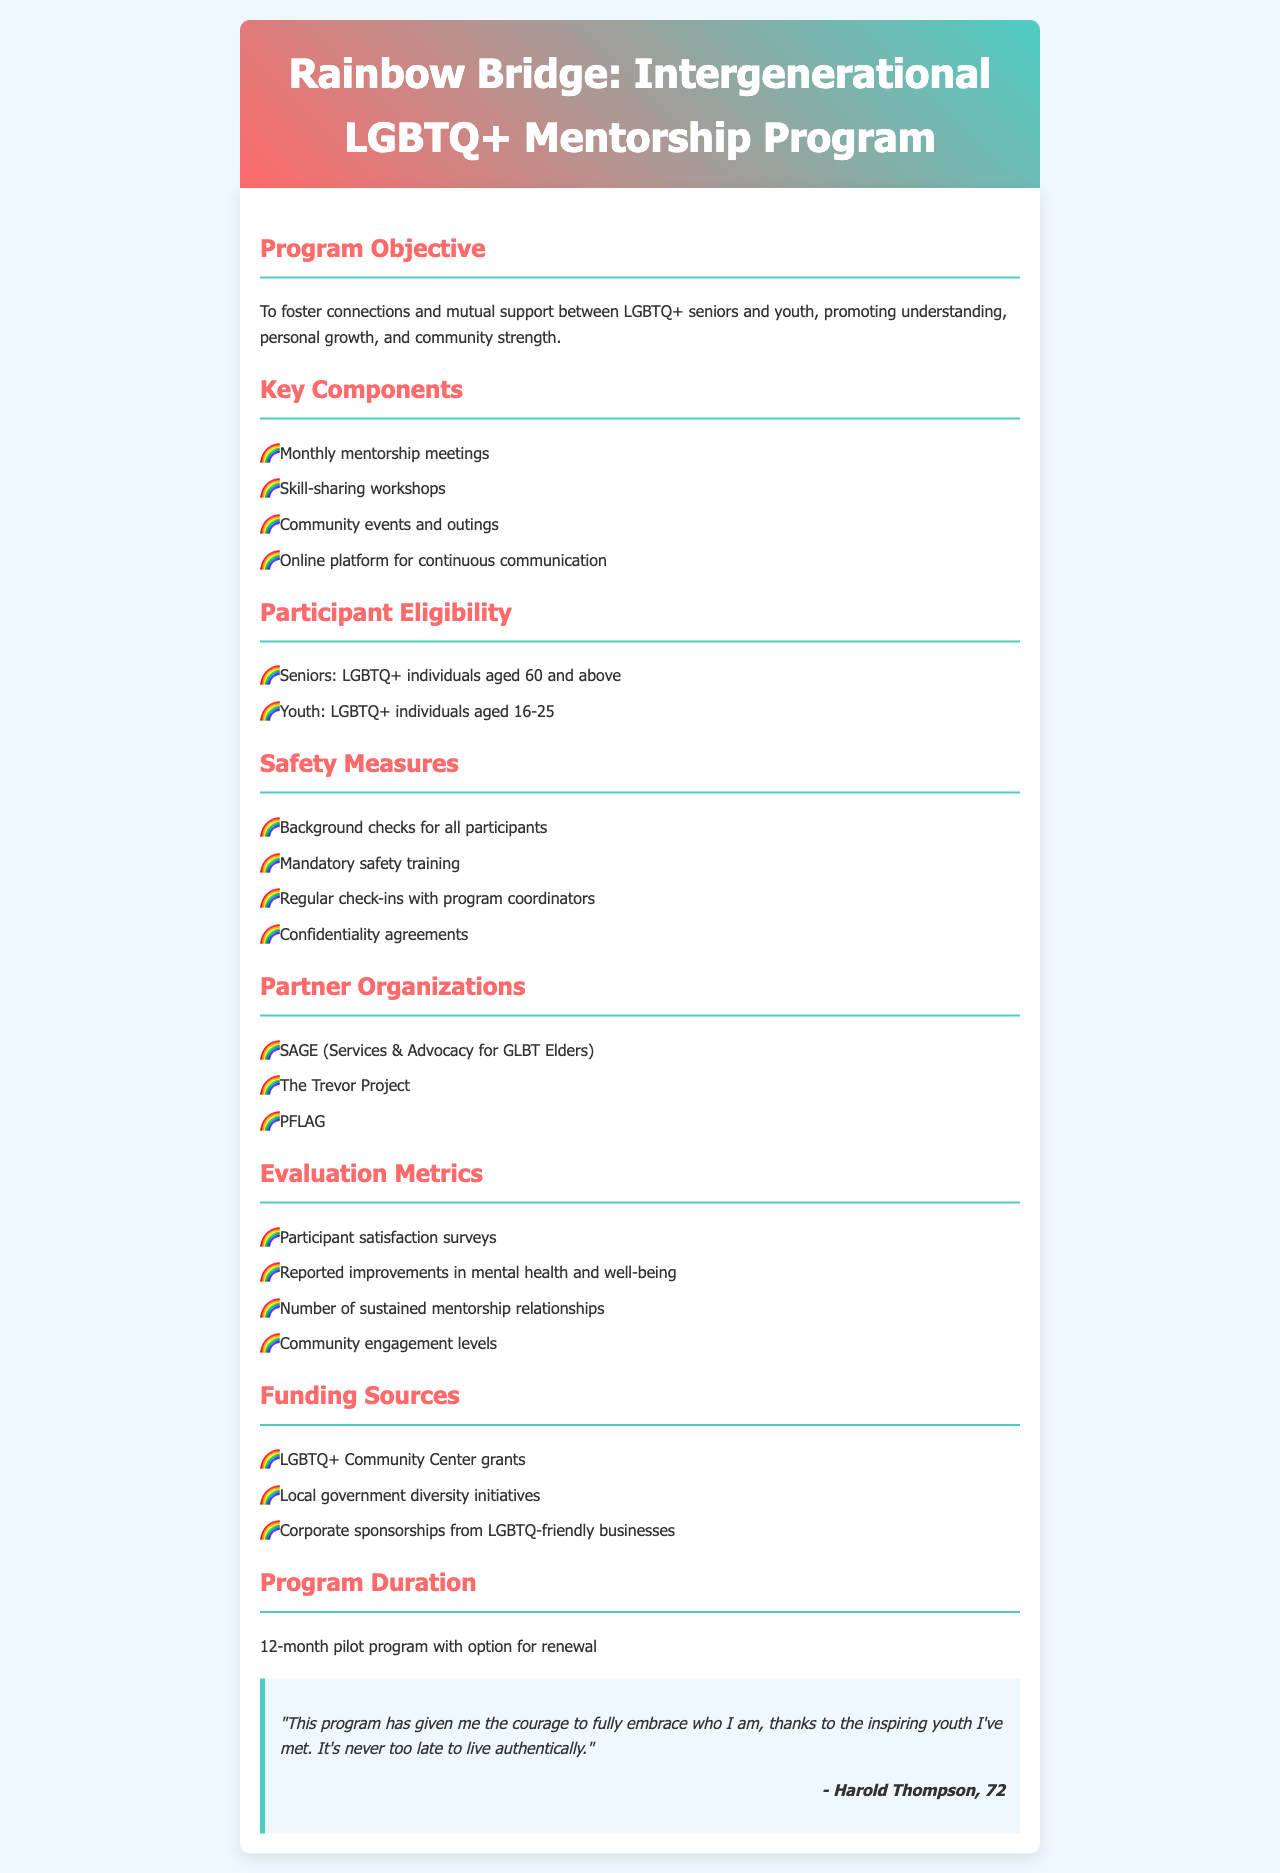What is the program's objective? The objective describes the purpose of the program, which is to foster connections and mutual support between LGBTQ+ seniors and youth.
Answer: To foster connections and mutual support What is the age range for youth participants? The document specifies the eligible age range for youth participants in the program.
Answer: 16-25 What organization is partnered with the program for advocacy? A partner organization listed in the document that advocates for LGBTQ+ elders.
Answer: SAGE How long is the pilot program expected to run? The document mentions the duration of the pilot program.
Answer: 12-month What safety measure requires training? One of the safety measures described that entails mandatory training for participants.
Answer: Safety training What is one method used to evaluate the program's success? The document lists methods to assess participant satisfaction and program impact.
Answer: Satisfaction surveys What type of events are included in the program's key components? The key components mention specific social gatherings and activities for participants.
Answer: Community events and outings Who provided a testimonial in the document? A specific individual mentioned in a testimonial within the program description.
Answer: Harold Thompson What is the minimum age for senior participants? The document specifies the eligible age for senior participants in the program.
Answer: 60 